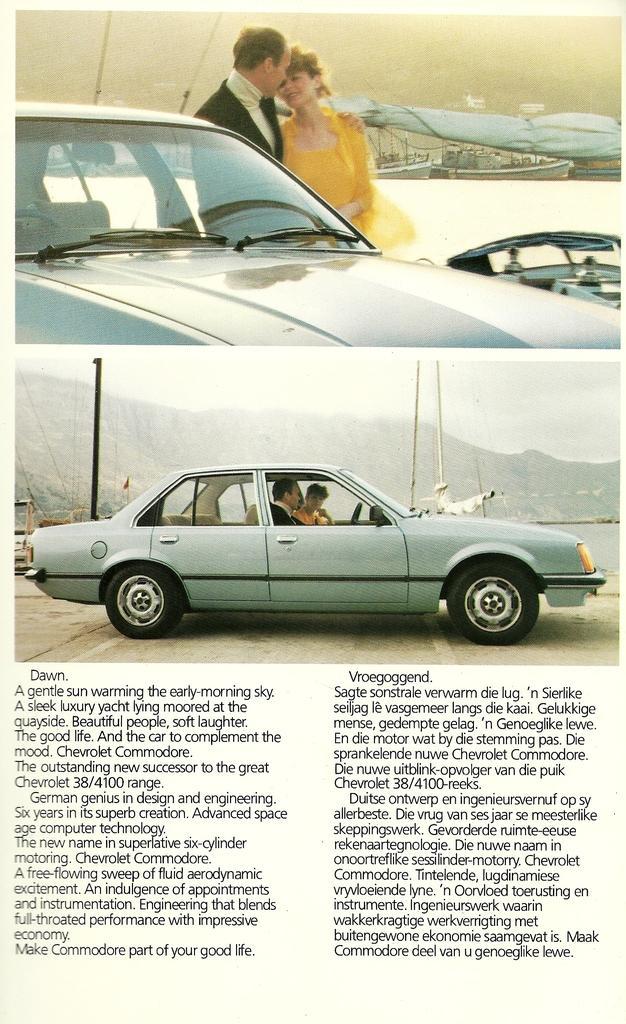Could you give a brief overview of what you see in this image? In this picture there is a man and a woman standing beside the car and the water body behind them and in this picture the men and women are sitting inside the car and there is a mountain in the backdrop 